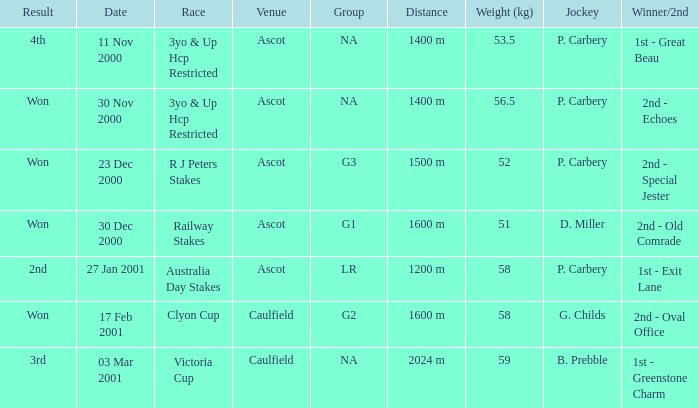What collective information can be found for the 5 NA. 